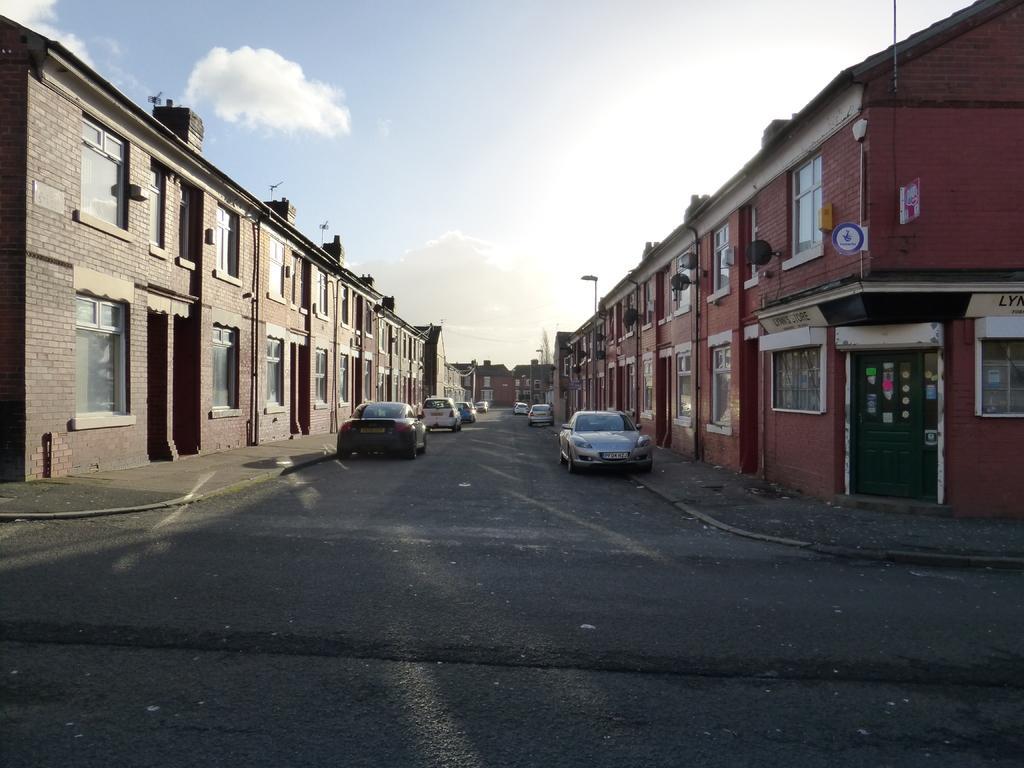Can you describe this image briefly? In this picture we can see few buildings and vehicles on the road, in the background we can see few poles and clouds. 